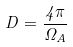Convert formula to latex. <formula><loc_0><loc_0><loc_500><loc_500>D = \frac { 4 \pi } { \Omega _ { A } }</formula> 